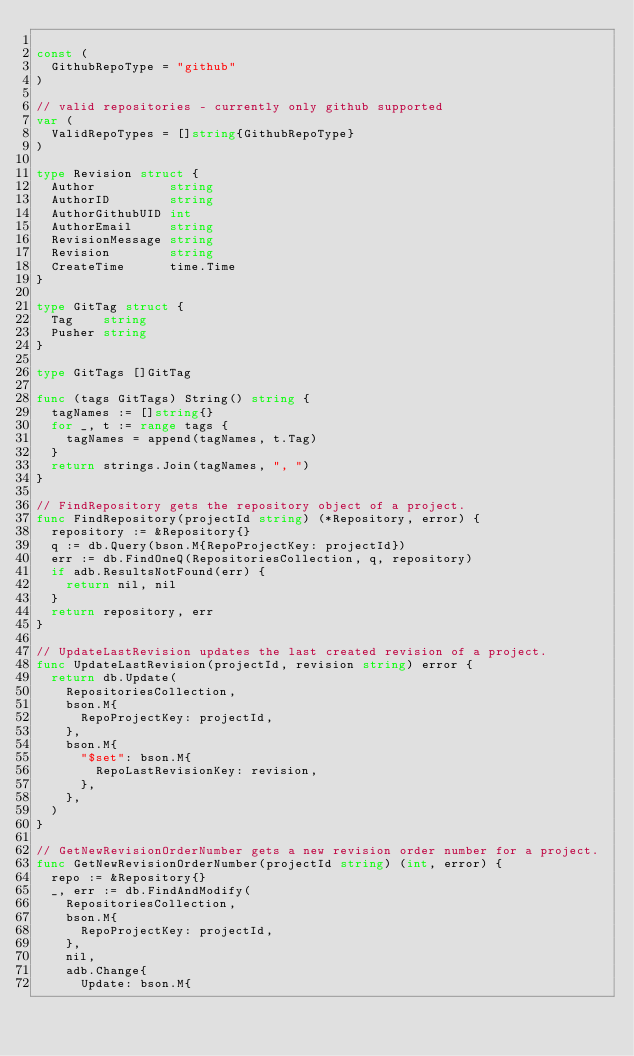Convert code to text. <code><loc_0><loc_0><loc_500><loc_500><_Go_>
const (
	GithubRepoType = "github"
)

// valid repositories - currently only github supported
var (
	ValidRepoTypes = []string{GithubRepoType}
)

type Revision struct {
	Author          string
	AuthorID        string
	AuthorGithubUID int
	AuthorEmail     string
	RevisionMessage string
	Revision        string
	CreateTime      time.Time
}

type GitTag struct {
	Tag    string
	Pusher string
}

type GitTags []GitTag

func (tags GitTags) String() string {
	tagNames := []string{}
	for _, t := range tags {
		tagNames = append(tagNames, t.Tag)
	}
	return strings.Join(tagNames, ", ")
}

// FindRepository gets the repository object of a project.
func FindRepository(projectId string) (*Repository, error) {
	repository := &Repository{}
	q := db.Query(bson.M{RepoProjectKey: projectId})
	err := db.FindOneQ(RepositoriesCollection, q, repository)
	if adb.ResultsNotFound(err) {
		return nil, nil
	}
	return repository, err
}

// UpdateLastRevision updates the last created revision of a project.
func UpdateLastRevision(projectId, revision string) error {
	return db.Update(
		RepositoriesCollection,
		bson.M{
			RepoProjectKey: projectId,
		},
		bson.M{
			"$set": bson.M{
				RepoLastRevisionKey: revision,
			},
		},
	)
}

// GetNewRevisionOrderNumber gets a new revision order number for a project.
func GetNewRevisionOrderNumber(projectId string) (int, error) {
	repo := &Repository{}
	_, err := db.FindAndModify(
		RepositoriesCollection,
		bson.M{
			RepoProjectKey: projectId,
		},
		nil,
		adb.Change{
			Update: bson.M{</code> 